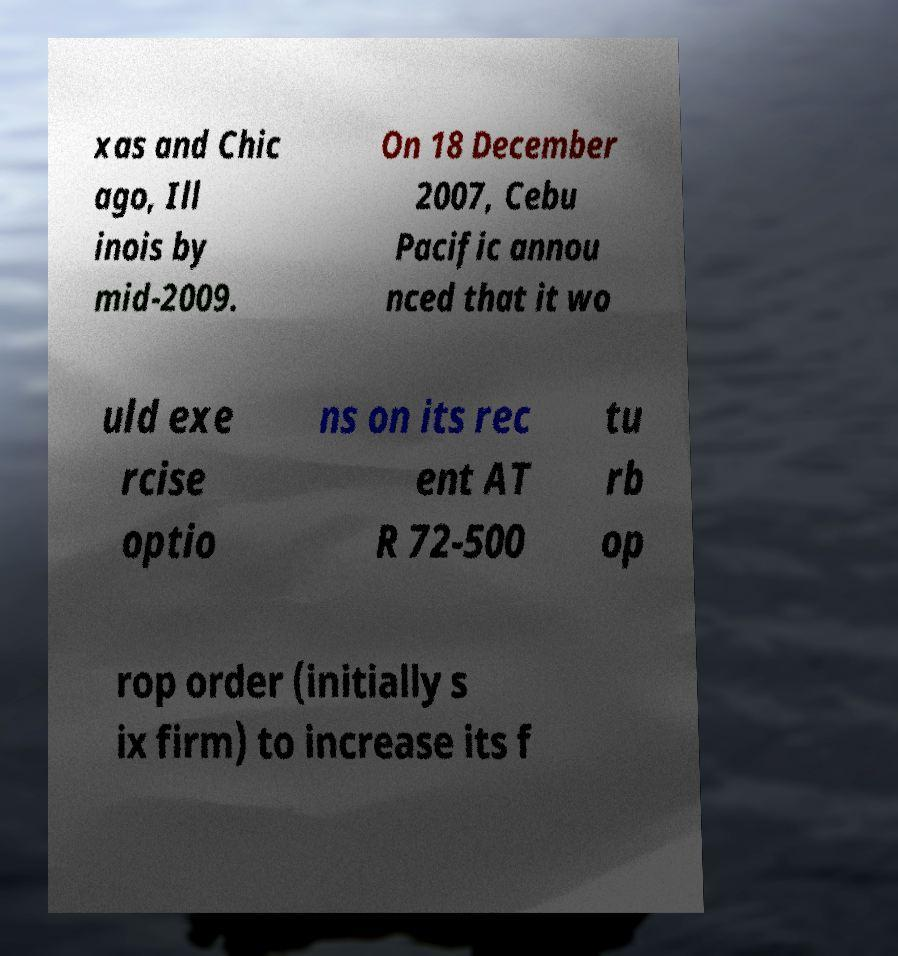Can you read and provide the text displayed in the image?This photo seems to have some interesting text. Can you extract and type it out for me? xas and Chic ago, Ill inois by mid-2009. On 18 December 2007, Cebu Pacific annou nced that it wo uld exe rcise optio ns on its rec ent AT R 72-500 tu rb op rop order (initially s ix firm) to increase its f 